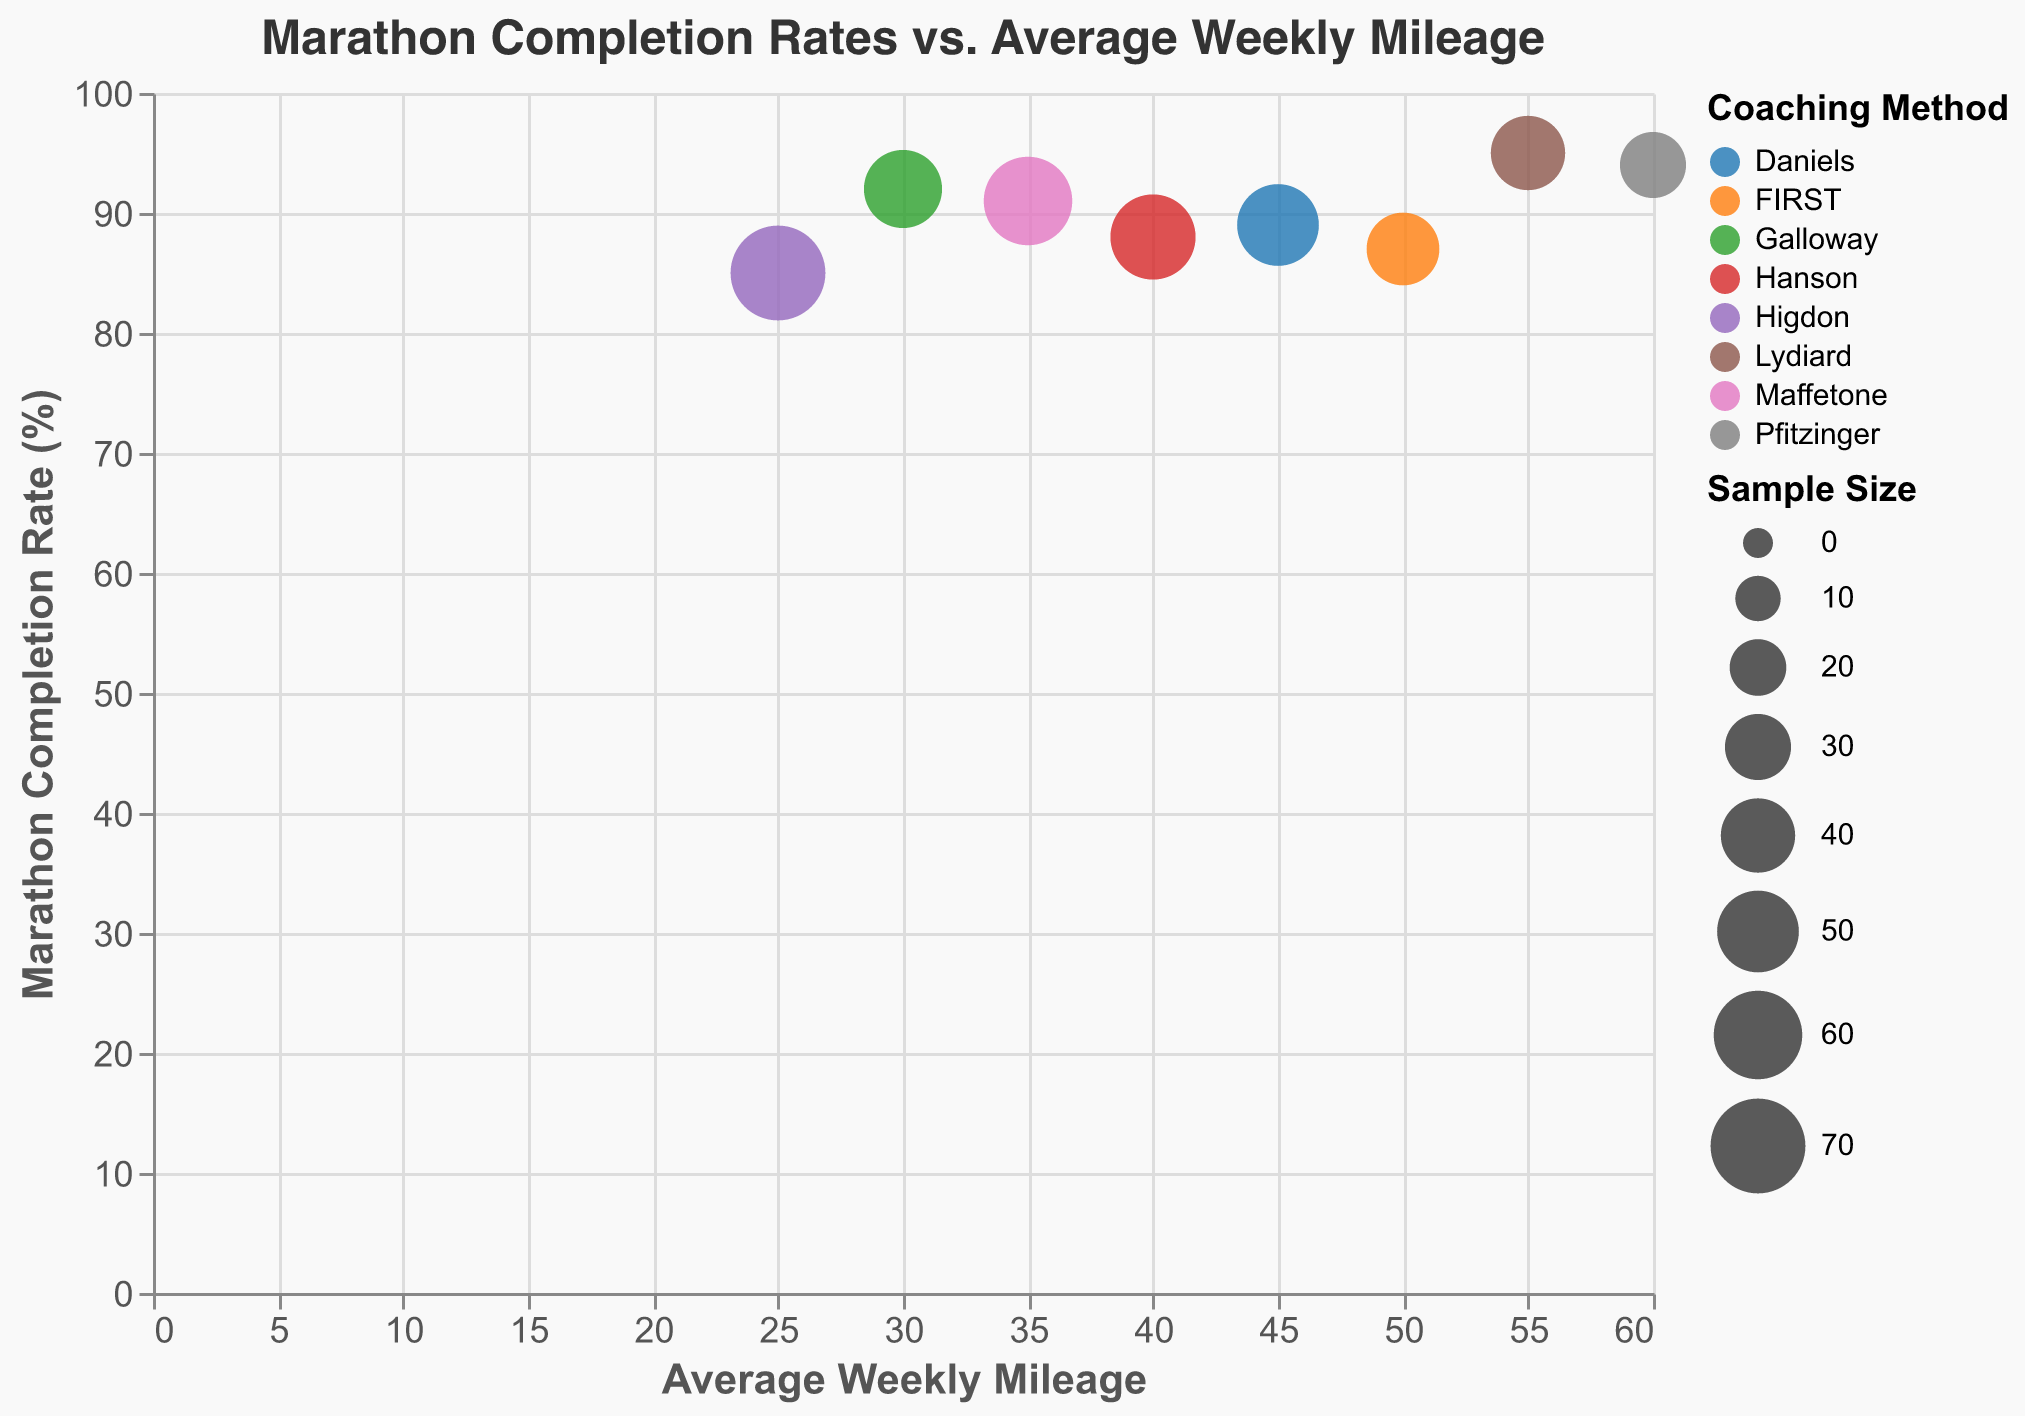How many coaching methods are displayed in the chart? The chart visually represents each coaching method with a different color. By counting the number of unique colors or distinct method names in the legend, we find there are 8 coaching methods.
Answer: 8 Which coaching method has the highest average weekly mileage? The coaching methods are plotted along the x-axis representing average weekly mileage. The method with the largest x-coordinate is Pfitzinger, which corresponds to 60 miles.
Answer: Pfitzinger What is the difference in marathon completion rates between the Galloway and Higdon coaching methods? Galloway has a marathon completion rate of 92%, while Higdon has 85%. Subtracting 85 from 92 gives the difference: 92 - 85 = 7.
Answer: 7% Which coaching method has the highest marathon completion rate? By checking the data points on the y-axis representing marathon completion rate, the method associated with the highest point is Lydiard with a completion rate of 95%.
Answer: Lydiard What is the combined sample size of the Daniels, Lydiard, and FIRST coaching methods? The sample sizes for these methods are: Daniels (50), Lydiard (40), and FIRST (38). Adding these up, we get 50 + 40 + 38 = 128.
Answer: 128 Is the marathon completion rate of methods with an average weekly mileage of more than 50 miles all greater than 90%? The methods with more than 50 miles are Lydiard (55 miles, 95%) and Pfitzinger (60 miles, 94%). Both have completion rates greater than 90%.
Answer: Yes What is the average marathon completion rate of the Galloway, Hanson, and Maffetone coaching methods? The completion rates are Galloway (92%), Hanson (88%), and Maffetone (91%). The average is calculated as (92 + 88 + 91) / 3 = 271 / 3 ≈ 90.33.
Answer: Approximately 90.33% Which coaching method has the smallest sample size and what is it? The sizes of the circles represent the sample sizes. The smallest circle corresponds to Pfitzinger with a sample size of 30.
Answer: Pfitzinger, 30 How does the coaching method 'Hanson' compare to 'Maffetone' in terms of average weekly mileage and marathon completion rate? Hanson's average weekly mileage is 40 miles and a completion rate of 88%, whereas Maffetone has 35 miles and a completion rate of 91%.
Answer: Hanson has more mileage but lower completion rate What is the range of average weekly mileage among the coaching methods? The lowest average weekly mileage is from Higdon with 25 miles, and the highest is from Pfitzinger with 60 miles. The range is 60 - 25 = 35.
Answer: 35 